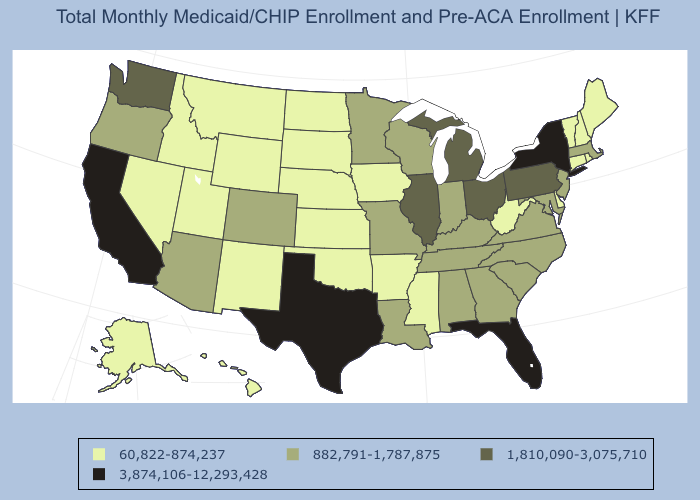Which states have the lowest value in the MidWest?
Keep it brief. Iowa, Kansas, Nebraska, North Dakota, South Dakota. Which states have the lowest value in the USA?
Give a very brief answer. Alaska, Arkansas, Connecticut, Delaware, Hawaii, Idaho, Iowa, Kansas, Maine, Mississippi, Montana, Nebraska, Nevada, New Hampshire, New Mexico, North Dakota, Oklahoma, Rhode Island, South Dakota, Utah, Vermont, West Virginia, Wyoming. Among the states that border West Virginia , does Pennsylvania have the highest value?
Answer briefly. Yes. Name the states that have a value in the range 882,791-1,787,875?
Concise answer only. Alabama, Arizona, Colorado, Georgia, Indiana, Kentucky, Louisiana, Maryland, Massachusetts, Minnesota, Missouri, New Jersey, North Carolina, Oregon, South Carolina, Tennessee, Virginia, Wisconsin. Among the states that border South Dakota , does Minnesota have the highest value?
Answer briefly. Yes. What is the highest value in states that border Florida?
Be succinct. 882,791-1,787,875. Name the states that have a value in the range 1,810,090-3,075,710?
Short answer required. Illinois, Michigan, Ohio, Pennsylvania, Washington. Does the first symbol in the legend represent the smallest category?
Keep it brief. Yes. What is the value of Iowa?
Give a very brief answer. 60,822-874,237. Name the states that have a value in the range 60,822-874,237?
Be succinct. Alaska, Arkansas, Connecticut, Delaware, Hawaii, Idaho, Iowa, Kansas, Maine, Mississippi, Montana, Nebraska, Nevada, New Hampshire, New Mexico, North Dakota, Oklahoma, Rhode Island, South Dakota, Utah, Vermont, West Virginia, Wyoming. Which states hav the highest value in the Northeast?
Short answer required. New York. What is the lowest value in the South?
Write a very short answer. 60,822-874,237. Does Colorado have a lower value than Mississippi?
Be succinct. No. Which states have the lowest value in the West?
Quick response, please. Alaska, Hawaii, Idaho, Montana, Nevada, New Mexico, Utah, Wyoming. Does Missouri have the lowest value in the USA?
Give a very brief answer. No. 